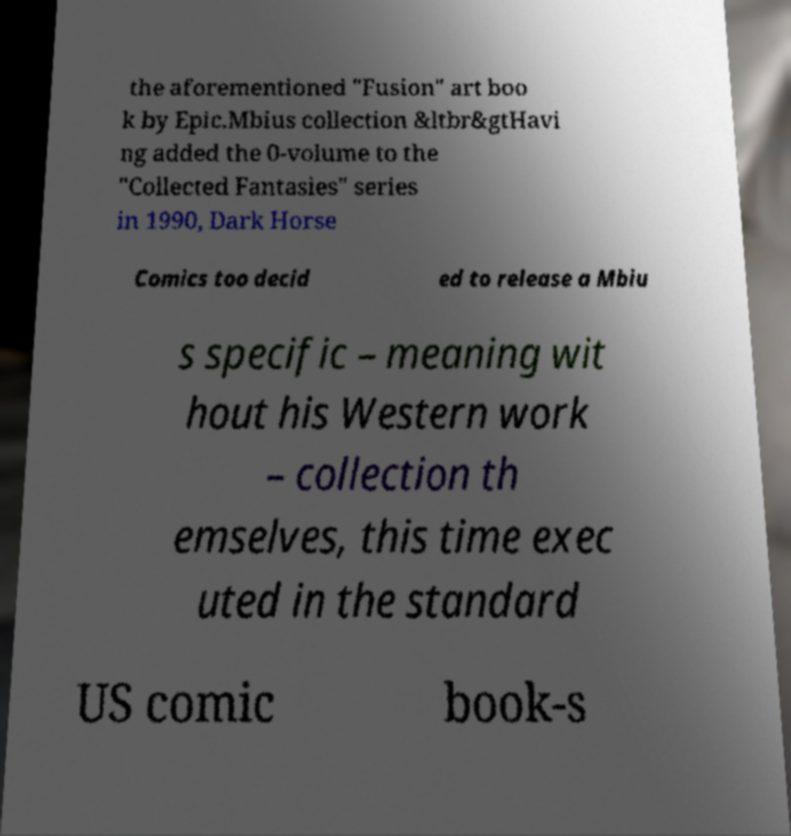Can you read and provide the text displayed in the image?This photo seems to have some interesting text. Can you extract and type it out for me? the aforementioned "Fusion" art boo k by Epic.Mbius collection &ltbr&gtHavi ng added the 0-volume to the "Collected Fantasies" series in 1990, Dark Horse Comics too decid ed to release a Mbiu s specific – meaning wit hout his Western work – collection th emselves, this time exec uted in the standard US comic book-s 